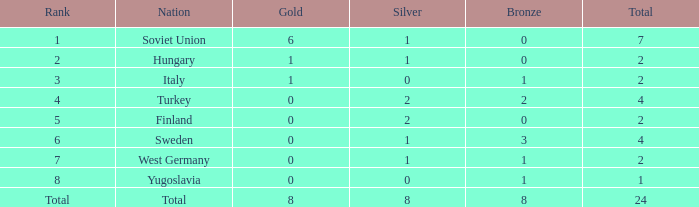What is the highest Total, when Gold is 1, when Nation is Hungary, and when Bronze is less than 0? None. 